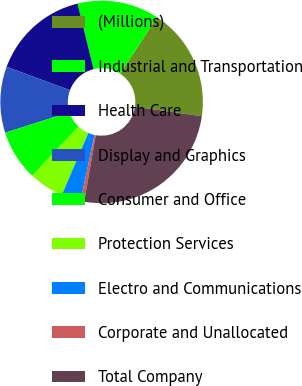Convert chart. <chart><loc_0><loc_0><loc_500><loc_500><pie_chart><fcel>(Millions)<fcel>Industrial and Transportation<fcel>Health Care<fcel>Display and Graphics<fcel>Consumer and Office<fcel>Protection Services<fcel>Electro and Communications<fcel>Corporate and Unallocated<fcel>Total Company<nl><fcel>18.03%<fcel>13.05%<fcel>15.54%<fcel>10.56%<fcel>8.07%<fcel>5.58%<fcel>3.08%<fcel>0.59%<fcel>25.5%<nl></chart> 